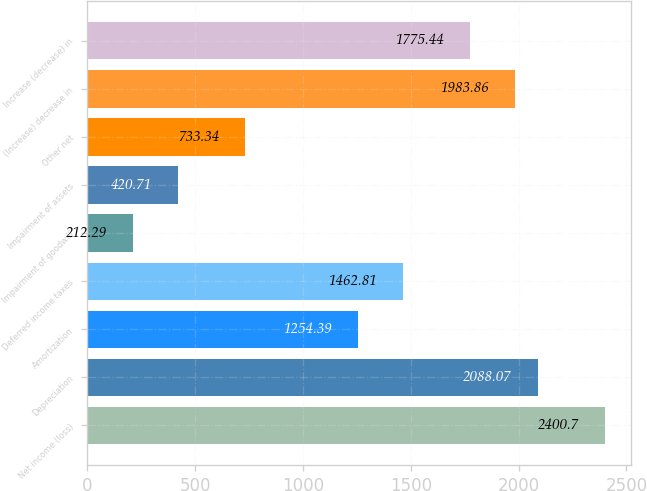Convert chart. <chart><loc_0><loc_0><loc_500><loc_500><bar_chart><fcel>Net income (loss)<fcel>Depreciation<fcel>Amortization<fcel>Deferred income taxes<fcel>Impairment of goodwill<fcel>Impairment of assets<fcel>Other net<fcel>(Increase) decrease in<fcel>Increase (decrease) in<nl><fcel>2400.7<fcel>2088.07<fcel>1254.39<fcel>1462.81<fcel>212.29<fcel>420.71<fcel>733.34<fcel>1983.86<fcel>1775.44<nl></chart> 